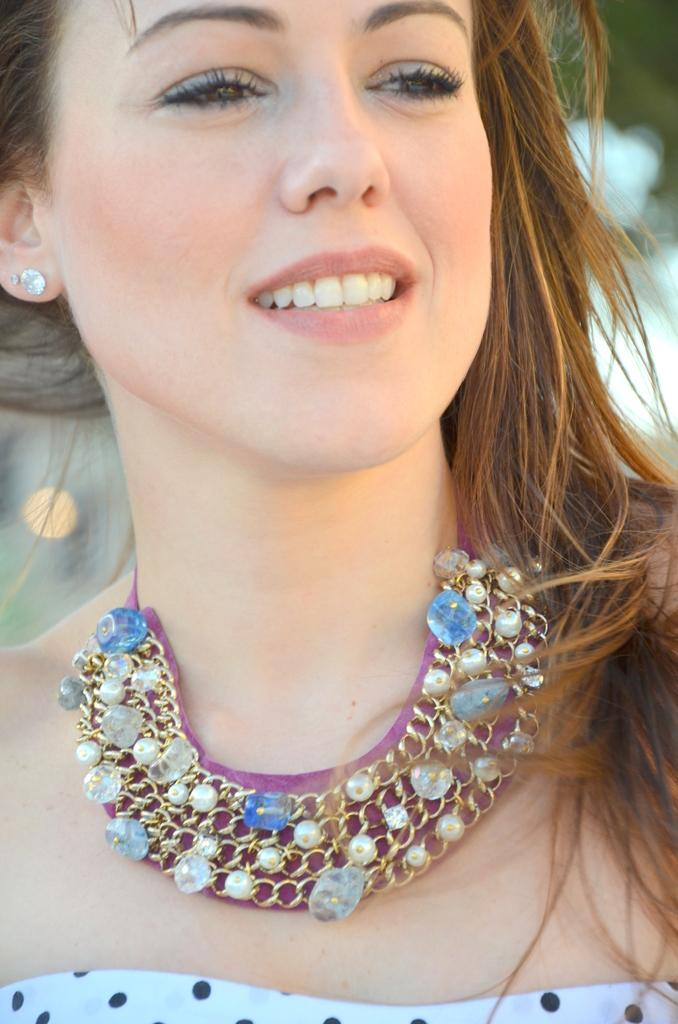What is present in the image? There is a person in the image. How does the person appear to be feeling? The person has a smile on her face, indicating a positive emotion. Can you describe the background of the image? The background of the image is blurred. What type of guitar is the person playing in the image? There is no guitar present in the image; it only features a person with a smile on her face. How many giants can be seen in the image? There are no giants present in the image. 